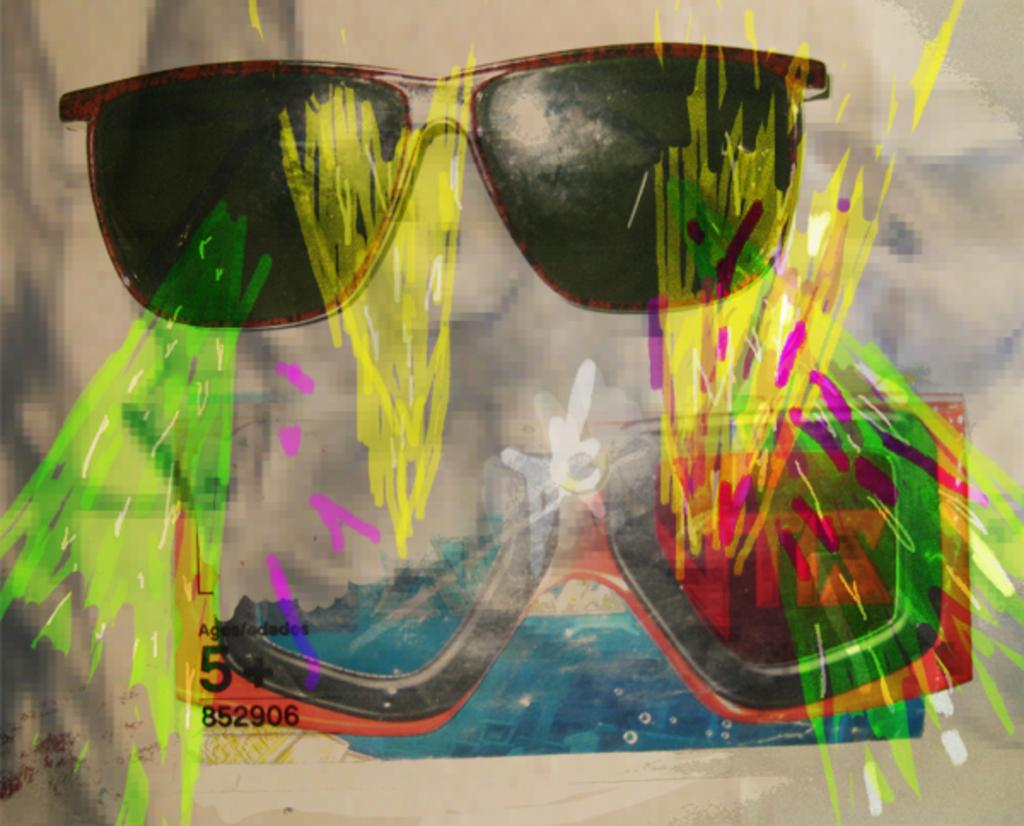What type of object can be seen in the image? There are spectacles in the image. What else can be seen in the image besides the spectacles? There are paintings in the image. Where is the toothbrush located in the image? There is no toothbrush present in the image. What type of mark can be seen on the paintings in the image? The provided facts do not mention any specific marks on the paintings, so we cannot answer this question definitively. 